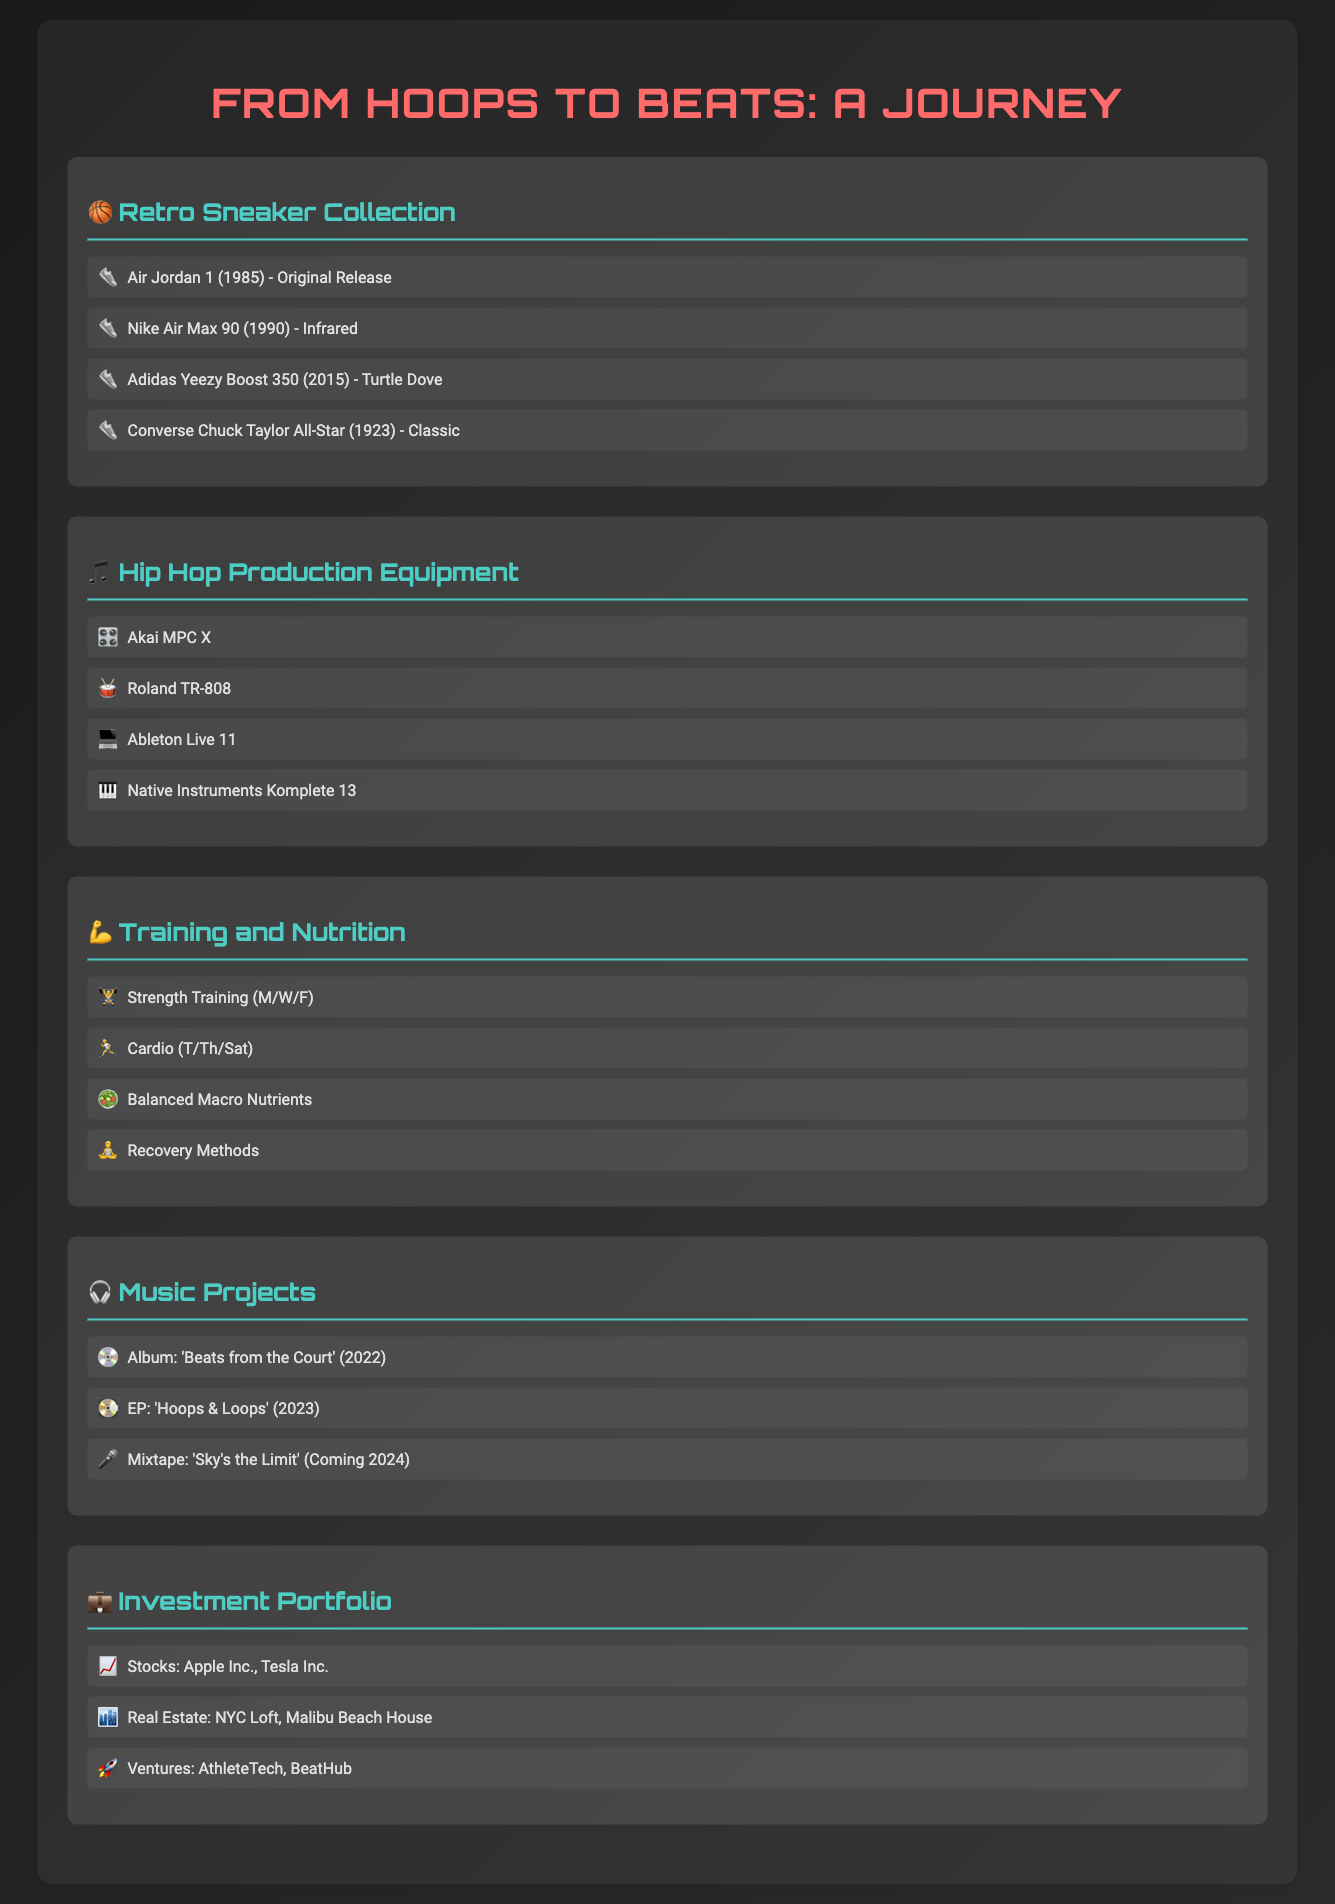What is the first sneaker listed in the Retro Sneaker Collection? The first sneaker mentioned in the collection is the Air Jordan 1, released in 1985.
Answer: Air Jordan 1 (1985) - Original Release What year was the Adidas Yeezy Boost 350 released? The Adidas Yeezy Boost 350 is listed with a release year of 2015.
Answer: 2015 What music project is coming in 2024? The document lists a mixtape titled 'Sky's the Limit' as coming in 2024.
Answer: Sky's the Limit How many pieces of hip hop production equipment are listed? There are four pieces of hip hop production equipment mentioned in the inventory section.
Answer: 4 Which two companies' stocks are included in the investment portfolio? The investment portfolio references Apple Inc. and Tesla Inc. as stock holdings.
Answer: Apple Inc., Tesla Inc What is the focus of the training regimen mentioned in the document? The training regimen emphasizes strength training, cardio, balanced nutrition, and recovery methods for maintaining peak performance.
Answer: Strength training, cardio, balanced nutrition, recovery methods Which album was released in 2022? The document mentions an album titled 'Beats from the Court' that was released in 2022.
Answer: Beats from the Court What type of real estate properties are listed in the investment portfolio? The portfolio lists two types of real estate, which are a loft in NYC and a beach house in Malibu.
Answer: NYC Loft, Malibu Beach House 